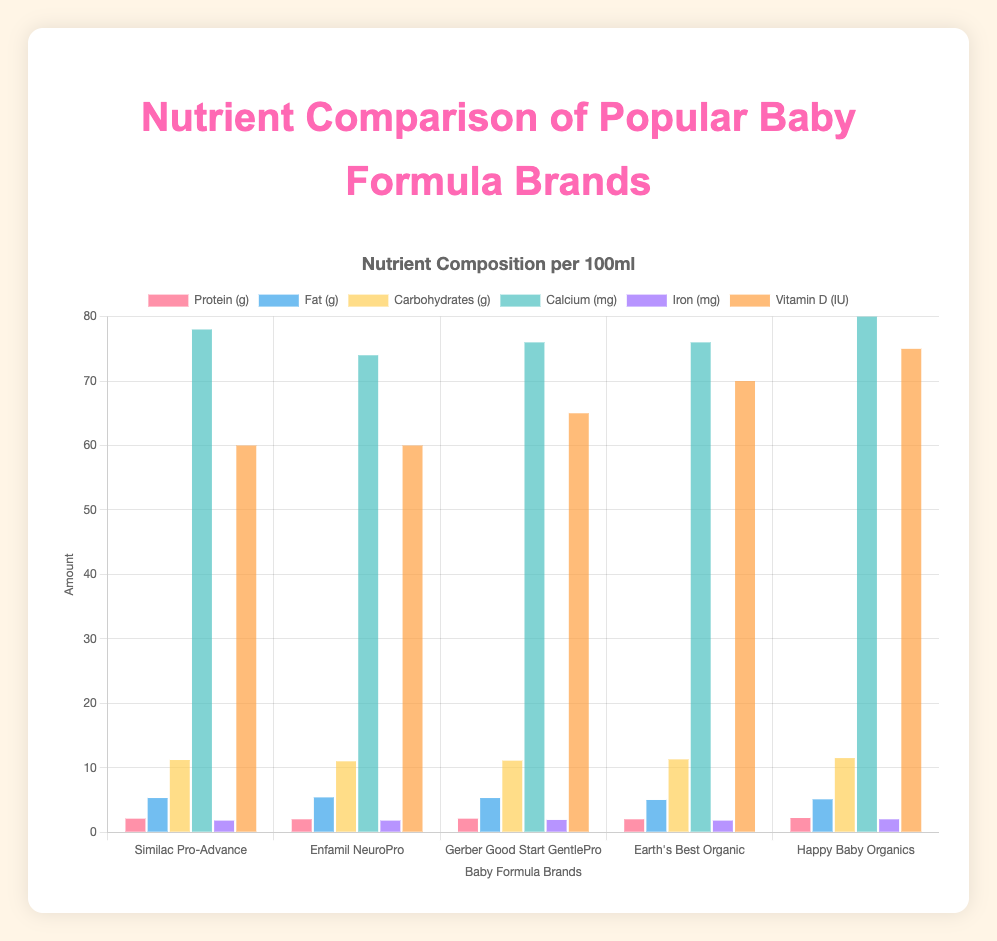Which baby formula has the highest calcium content? To find the highest calcium content, check the height of the bars for each formula brand in the calcium (mg) category. Happy Baby Organics has the highest bar, indicating the highest calcium content.
Answer: Happy Baby Organics Between Enfamil NeuroPro and Earth's Best Organic, which baby formula has a higher fat content? Compare the height of the fat (g) bars for Enfamil NeuroPro and Earth's Best Organic. Enfamil NeuroPro's bar is slightly higher than Earth's Best Organic.
Answer: Enfamil NeuroPro What is the difference in vitamin D content between Similac Pro-Advance and Happy Baby Organics? Locate the bars for vitamin D (IU) for both Similac Pro-Advance and Happy Baby Organics. Subtract the height of the Similac Pro-Advance bar (60) from that of the Happy Baby Organics bar (75).
Answer: 15 IU Which baby formula has the least amount of protein? To find the formula with the least protein, compare the height of the protein (g) bars. Enfamil NeuroPro and Earth's Best Organic have equal, and the least protein content.
Answer: Enfamil NeuroPro, Earth's Best Organic How does the carbohydrate content of Gerber Good Start GentlePro compare to Enfamil NeuroPro? Compare the height of the carbohydrate (g) bars for Gerber Good Start GentlePro and Enfamil NeuroPro. Gerber Good Start GentlePro's bar is slightly higher.
Answer: Gerber Good Start GentlePro Which brand has the highest iron content, and what is that content? Check the height of the iron (mg) bars. Happy Baby Organics has the highest bar, indicating the highest iron content.
Answer: Happy Baby Organics, 2.0 mg What is the average calcium content across all the brands? Add the calcium (mg) content for all brands: 78 (Similac) + 74 (Enfamil) + 76 (Gerber) + 76 (Earth’s Best) + 80 (Happy Baby). Divide by the number of brands, which is 5. Average = (78 + 74 + 76 + 76 + 80)/5 = 76.8 mg
Answer: 76.8 mg 